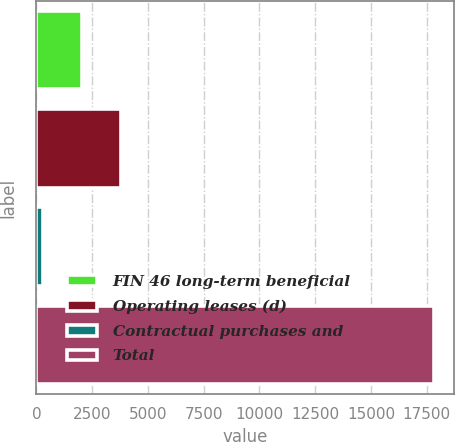<chart> <loc_0><loc_0><loc_500><loc_500><bar_chart><fcel>FIN 46 long-term beneficial<fcel>Operating leases (d)<fcel>Contractual purchases and<fcel>Total<nl><fcel>2052.3<fcel>3806.6<fcel>298<fcel>17841<nl></chart> 